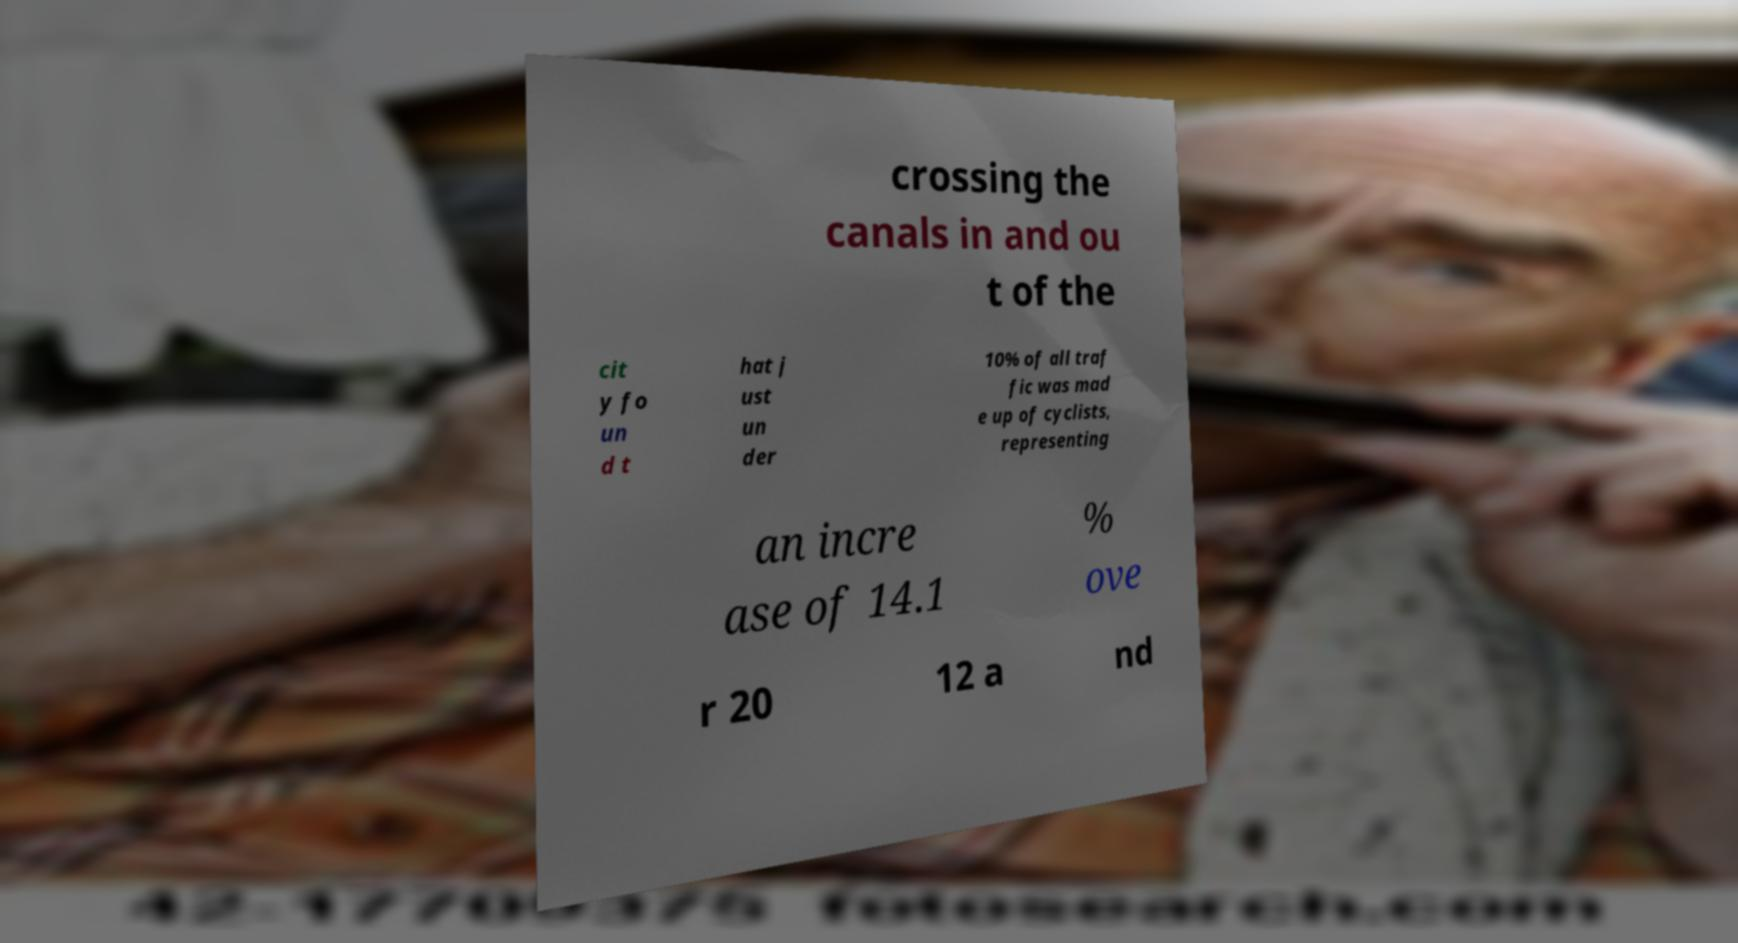Can you read and provide the text displayed in the image?This photo seems to have some interesting text. Can you extract and type it out for me? crossing the canals in and ou t of the cit y fo un d t hat j ust un der 10% of all traf fic was mad e up of cyclists, representing an incre ase of 14.1 % ove r 20 12 a nd 